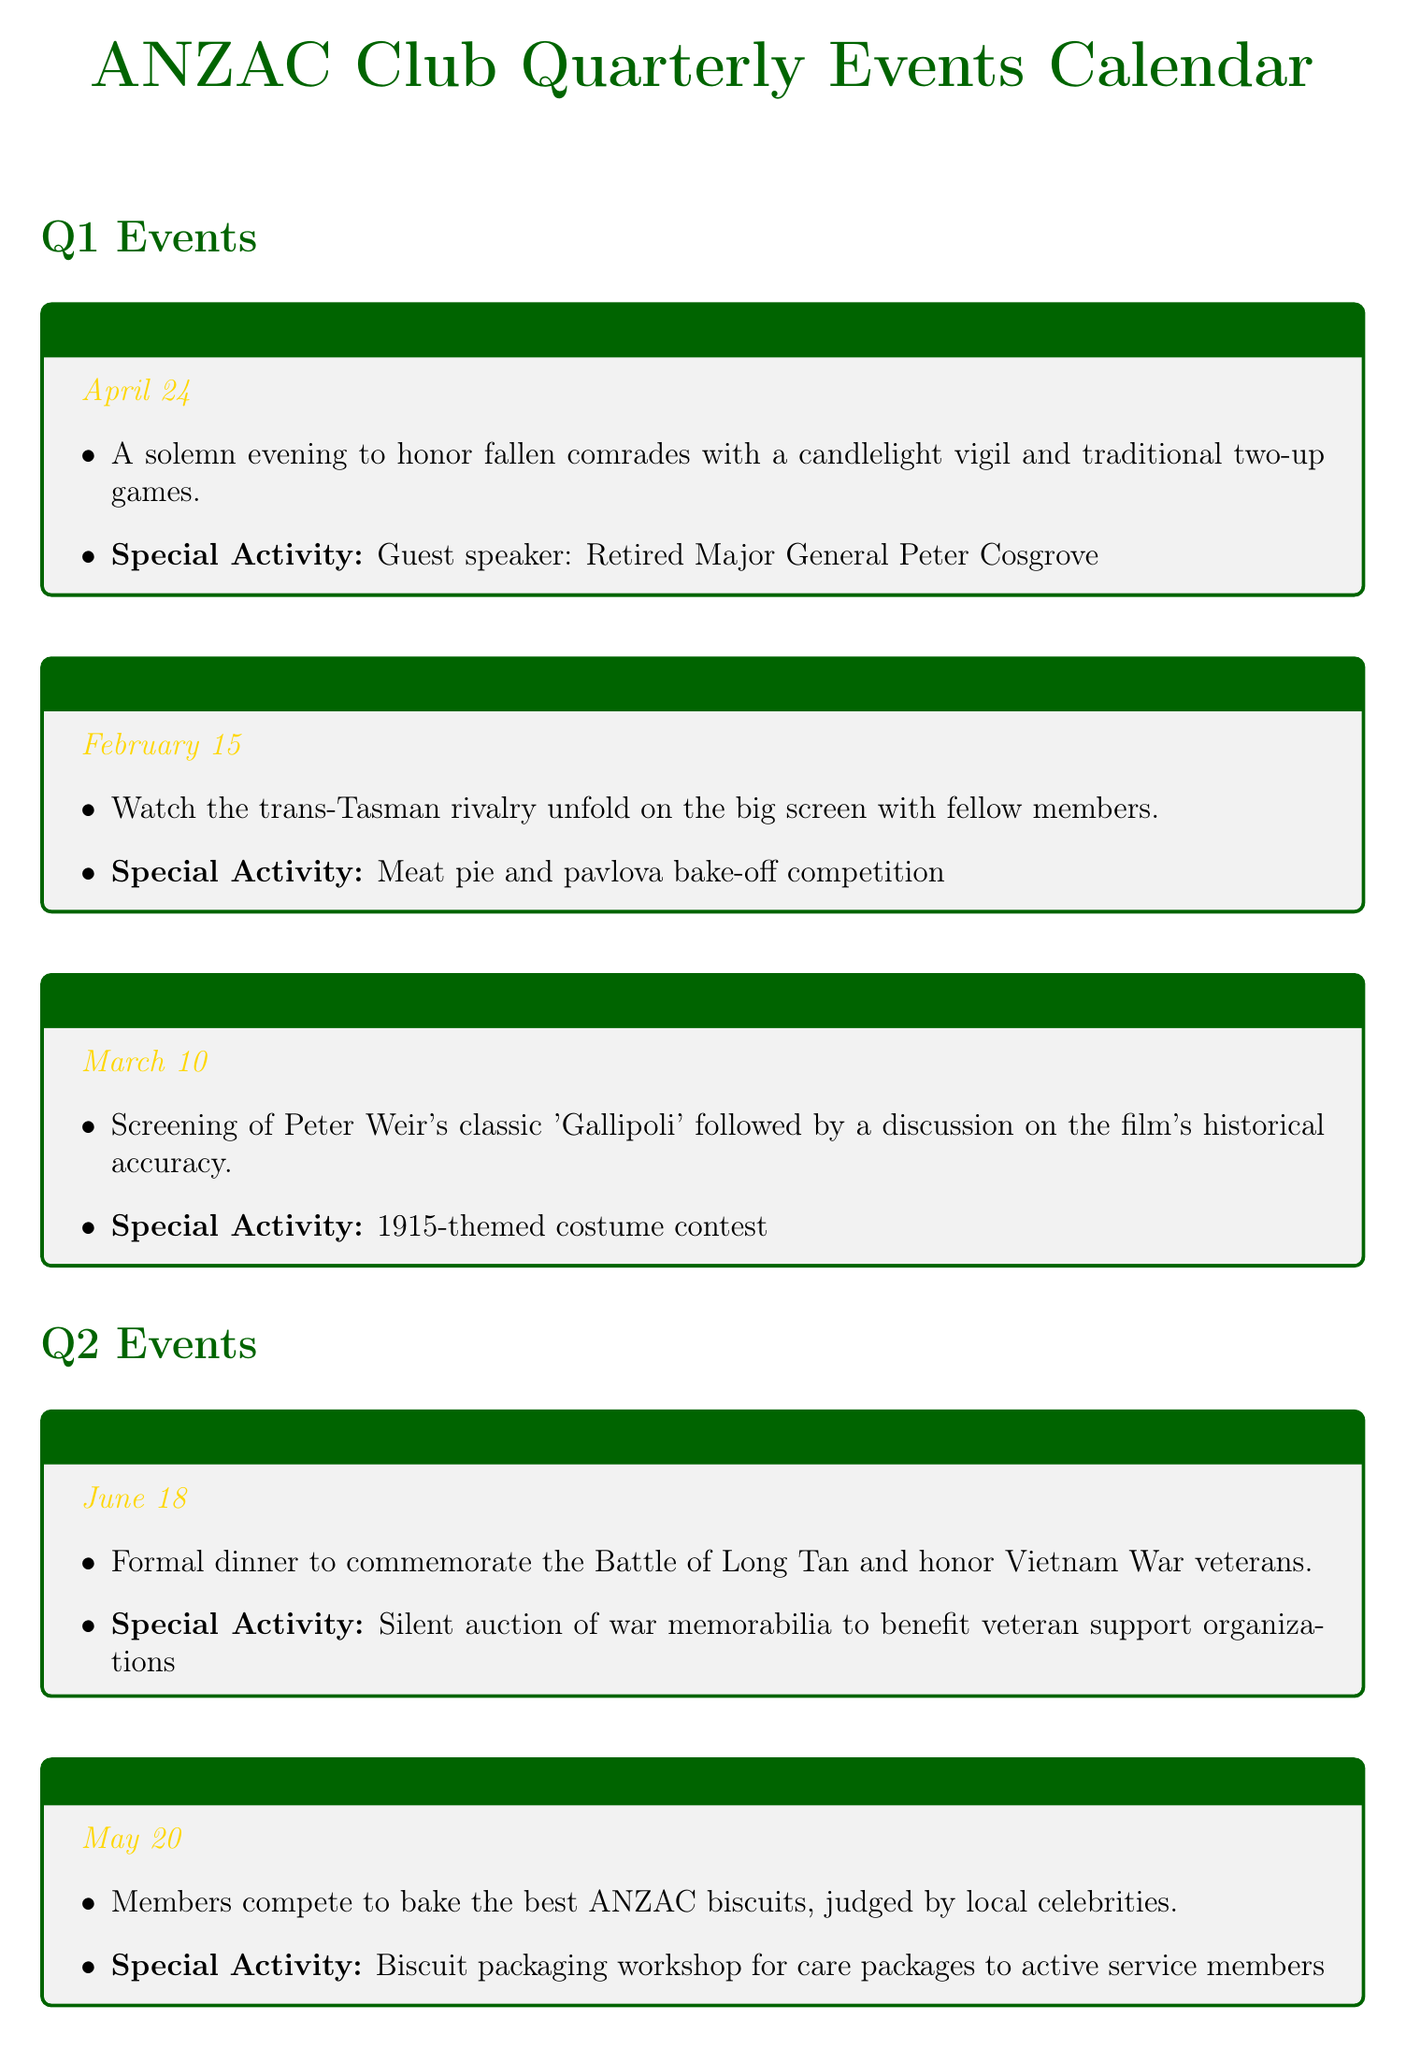What is the name of the event on April 24? The event on April 24 is titled "Anzac Day Eve Commemoration."
Answer: Anzac Day Eve Commemoration What special activity is planned for the Australia vs New Zealand Cricket Match Screening? The special activity for this event is "Meat pie and pavlova bake-off competition."
Answer: Meat pie and pavlova bake-off competition Which event includes a presentation by a Kokoda Track expert? The event that includes a presentation by a Kokoda Track expert is the "Kokoda Track Presentation Night."
Answer: Kokoda Track Presentation Night How many events are scheduled for Q3? There are three events scheduled for Q3, which are listed in the document.
Answer: 3 What is the date of the ANZAC Christmas Party? The ANZAC Christmas Party is scheduled for December 15.
Answer: December 15 What themed dinner is featured at the Battle of Fromelles Remembrance? The themed dinner featured at the Battle of Fromelles Remembrance is "French-themed dinner."
Answer: French-themed dinner What is the primary focus of the Winter Woolies for Warriors Drive? The primary focus is to create warm items for veterans in need.
Answer: Create warm items for veterans What is the unique aspect of the biscuit competition in Q2? The unique aspect is that the biscuits are judged by local celebrities.
Answer: Judged by local celebrities What will participants make at the Remembrance Day Poppy Making Workshop? Participants will create handmade poppies for the Remembrance Day ceremony.
Answer: Handmade poppies 